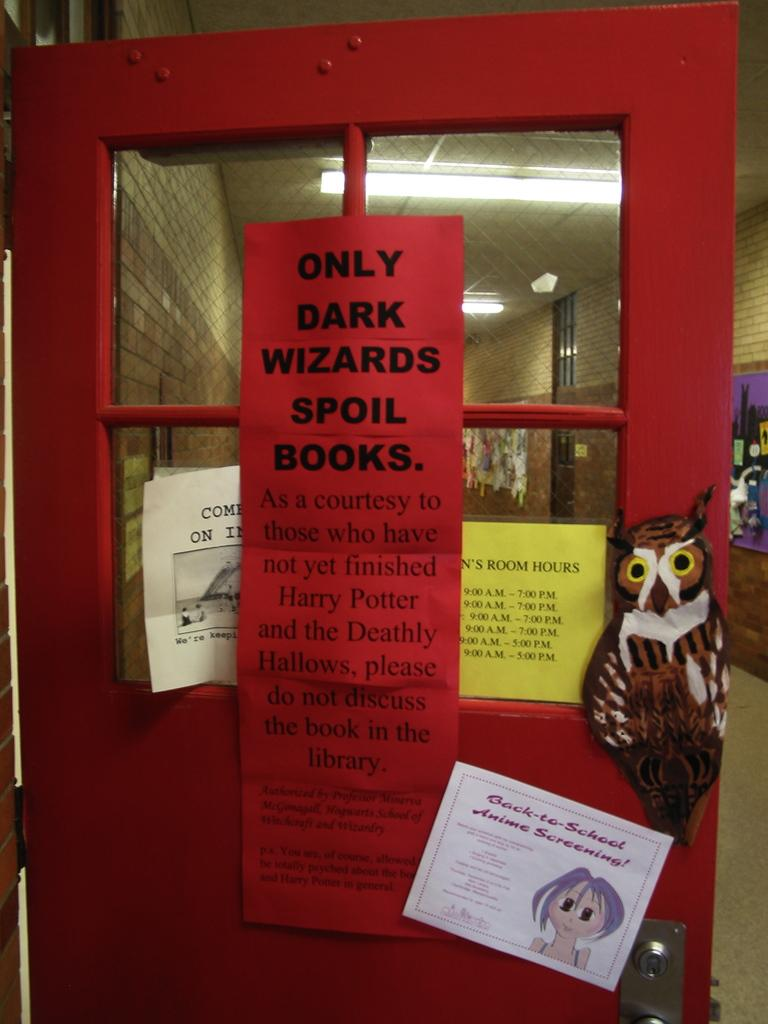<image>
Share a concise interpretation of the image provided. Inside of a school hallway with a red door opened with a cut out of a sticker and a sign say only dark wizards spoil books. 